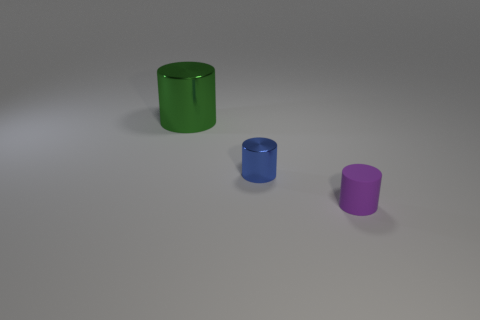Subtract all tiny metal cylinders. How many cylinders are left? 2 Add 3 small things. How many objects exist? 6 Subtract all purple cylinders. How many cylinders are left? 2 Subtract 3 cylinders. How many cylinders are left? 0 Subtract all blue cylinders. Subtract all gray blocks. How many cylinders are left? 2 Subtract all small matte cylinders. Subtract all blue shiny balls. How many objects are left? 2 Add 3 small purple rubber cylinders. How many small purple rubber cylinders are left? 4 Add 3 tiny green matte cylinders. How many tiny green matte cylinders exist? 3 Subtract 0 green blocks. How many objects are left? 3 